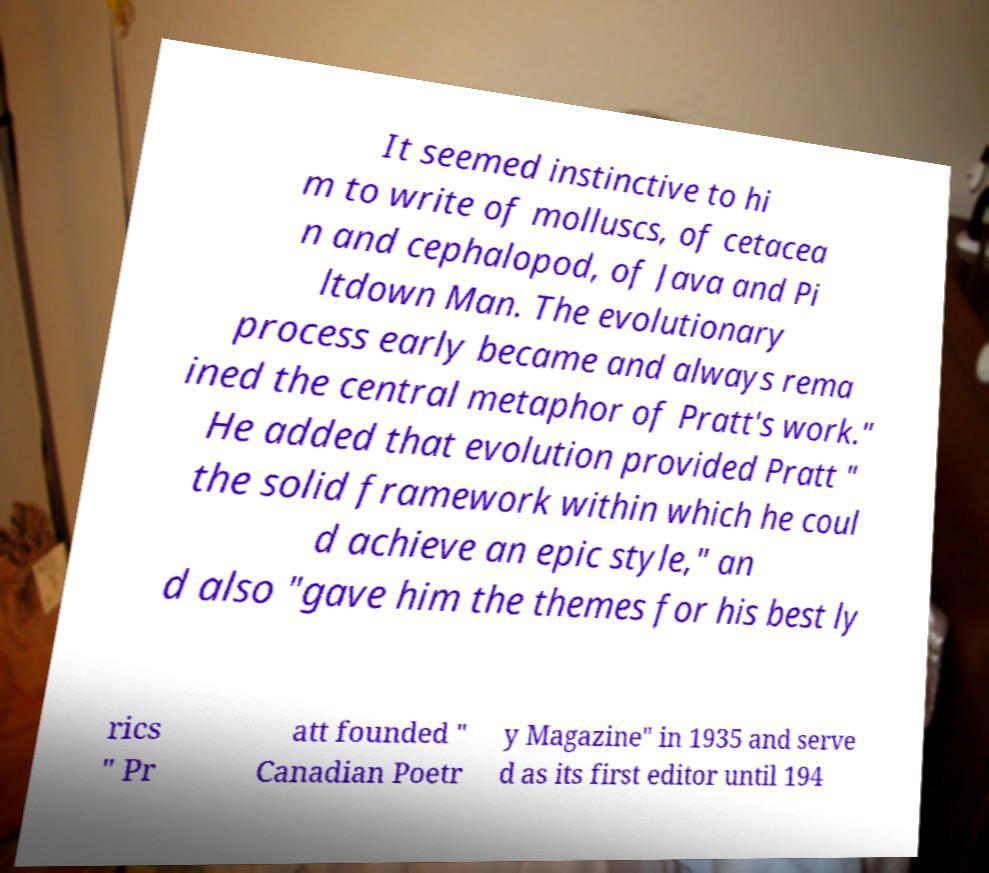Please read and relay the text visible in this image. What does it say? It seemed instinctive to hi m to write of molluscs, of cetacea n and cephalopod, of Java and Pi ltdown Man. The evolutionary process early became and always rema ined the central metaphor of Pratt's work." He added that evolution provided Pratt " the solid framework within which he coul d achieve an epic style," an d also "gave him the themes for his best ly rics " Pr att founded " Canadian Poetr y Magazine" in 1935 and serve d as its first editor until 194 